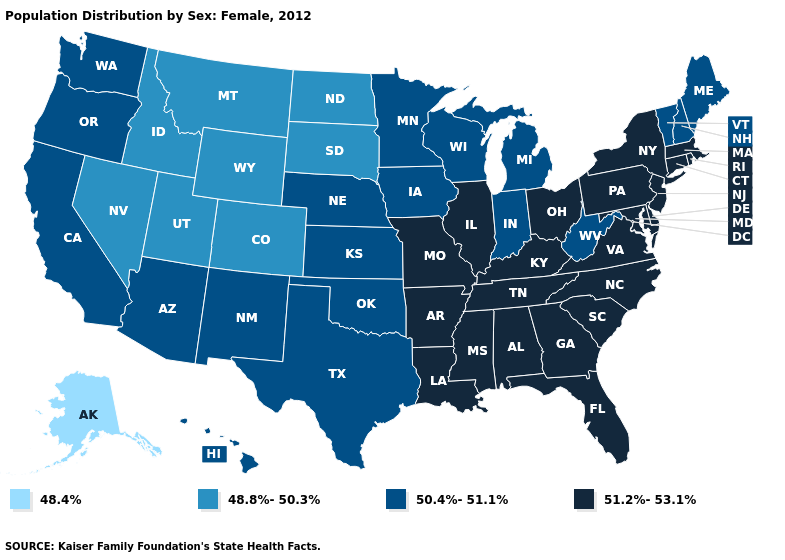How many symbols are there in the legend?
Write a very short answer. 4. Name the states that have a value in the range 48.8%-50.3%?
Quick response, please. Colorado, Idaho, Montana, Nevada, North Dakota, South Dakota, Utah, Wyoming. What is the value of Alabama?
Concise answer only. 51.2%-53.1%. What is the highest value in the USA?
Keep it brief. 51.2%-53.1%. Among the states that border Arkansas , does Texas have the lowest value?
Answer briefly. Yes. Among the states that border Wyoming , which have the lowest value?
Give a very brief answer. Colorado, Idaho, Montana, South Dakota, Utah. What is the value of Alaska?
Quick response, please. 48.4%. Among the states that border South Dakota , does Minnesota have the lowest value?
Quick response, please. No. Name the states that have a value in the range 48.4%?
Write a very short answer. Alaska. What is the value of Pennsylvania?
Write a very short answer. 51.2%-53.1%. What is the value of Louisiana?
Keep it brief. 51.2%-53.1%. Does the first symbol in the legend represent the smallest category?
Give a very brief answer. Yes. What is the lowest value in the USA?
Answer briefly. 48.4%. Among the states that border North Carolina , which have the lowest value?
Quick response, please. Georgia, South Carolina, Tennessee, Virginia. 